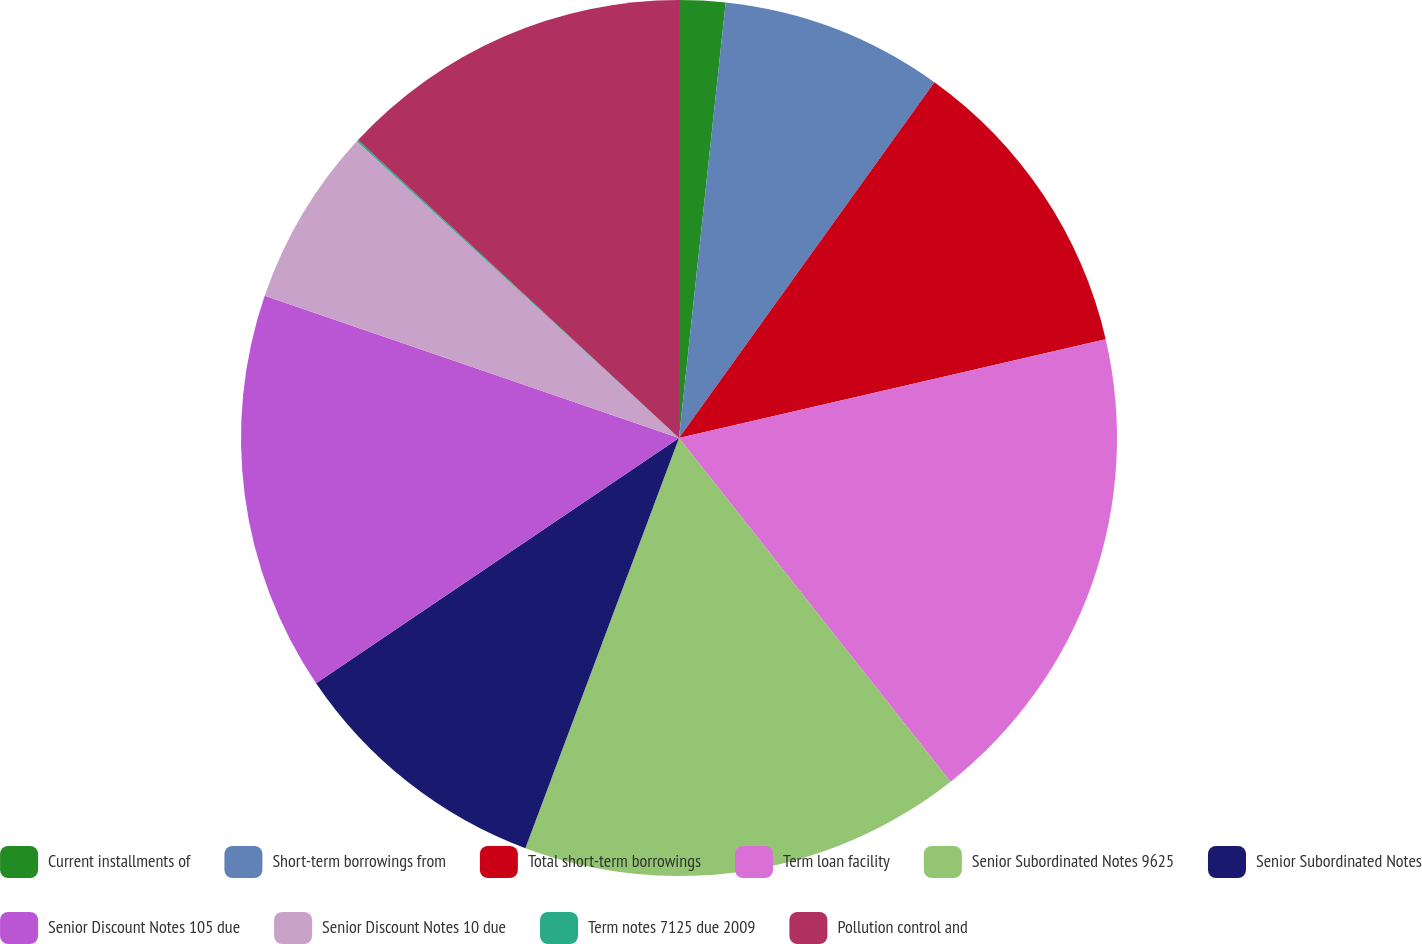<chart> <loc_0><loc_0><loc_500><loc_500><pie_chart><fcel>Current installments of<fcel>Short-term borrowings from<fcel>Total short-term borrowings<fcel>Term loan facility<fcel>Senior Subordinated Notes 9625<fcel>Senior Subordinated Notes<fcel>Senior Discount Notes 105 due<fcel>Senior Discount Notes 10 due<fcel>Term notes 7125 due 2009<fcel>Pollution control and<nl><fcel>1.7%<fcel>8.21%<fcel>11.47%<fcel>17.98%<fcel>16.35%<fcel>9.84%<fcel>14.72%<fcel>6.58%<fcel>0.07%<fcel>13.09%<nl></chart> 